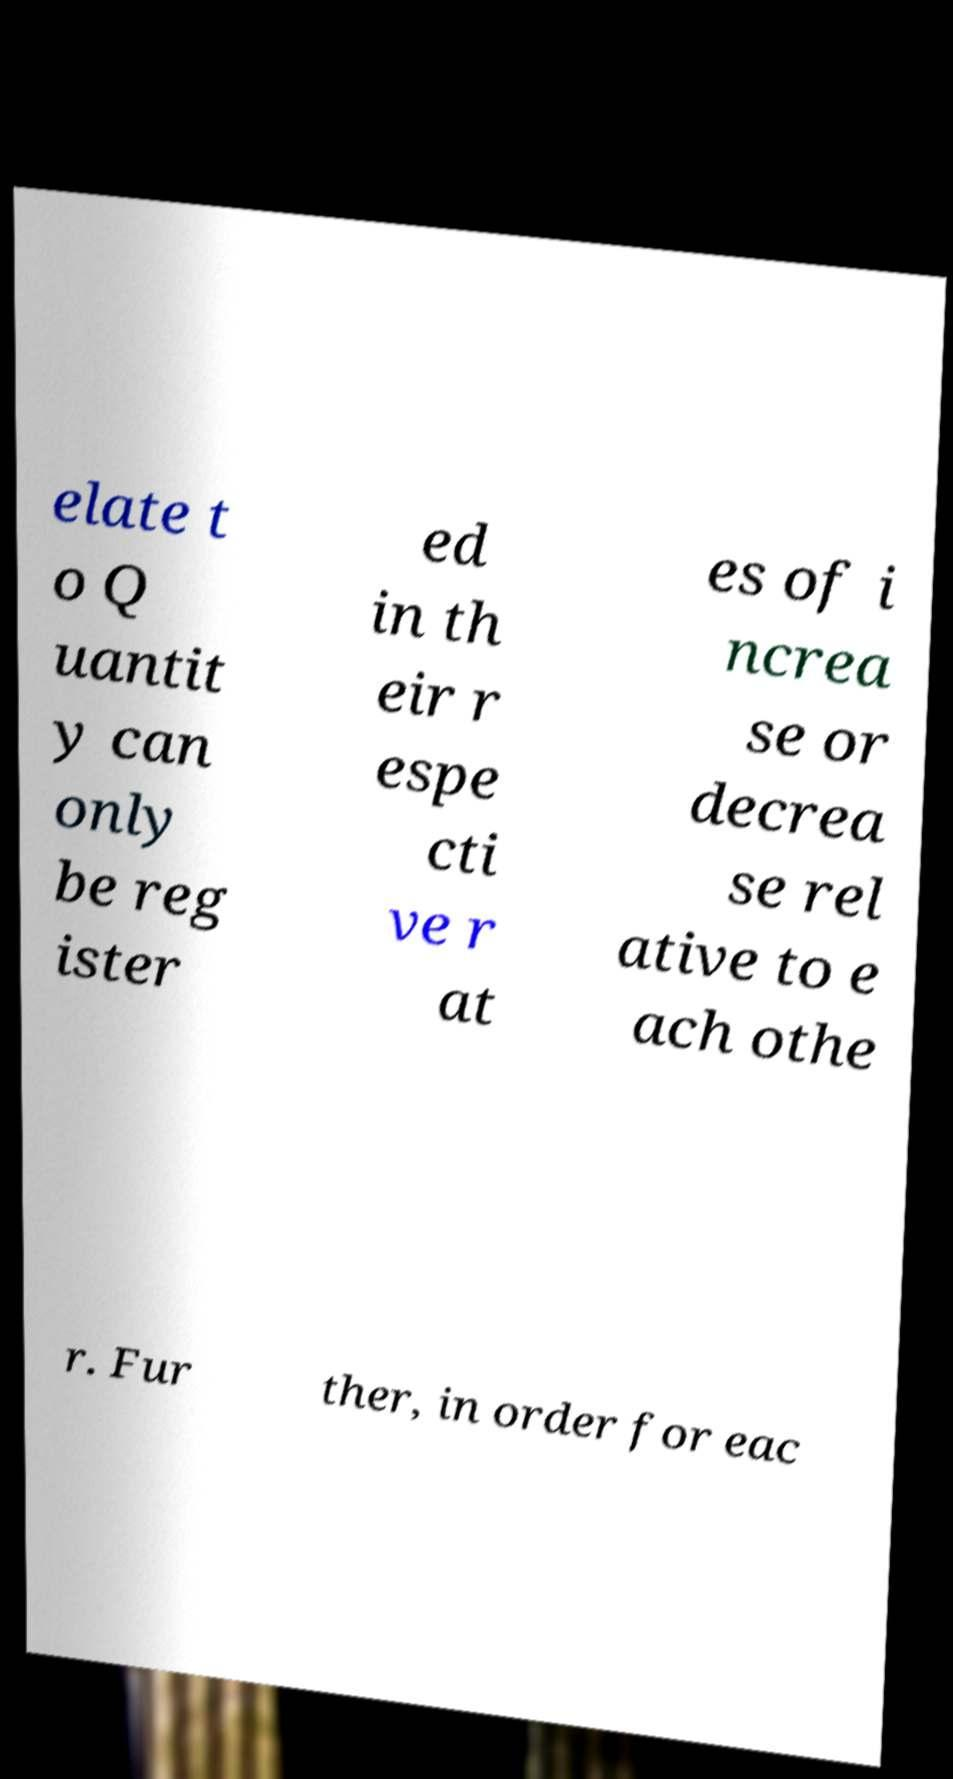Please identify and transcribe the text found in this image. elate t o Q uantit y can only be reg ister ed in th eir r espe cti ve r at es of i ncrea se or decrea se rel ative to e ach othe r. Fur ther, in order for eac 